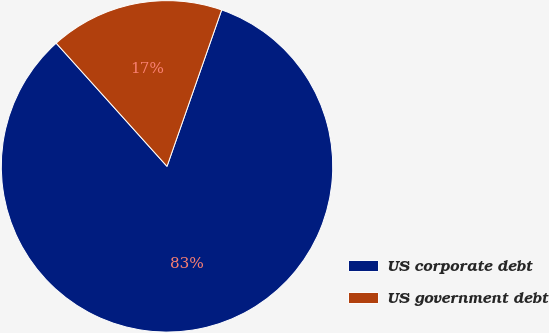<chart> <loc_0><loc_0><loc_500><loc_500><pie_chart><fcel>US corporate debt<fcel>US government debt<nl><fcel>82.99%<fcel>17.01%<nl></chart> 